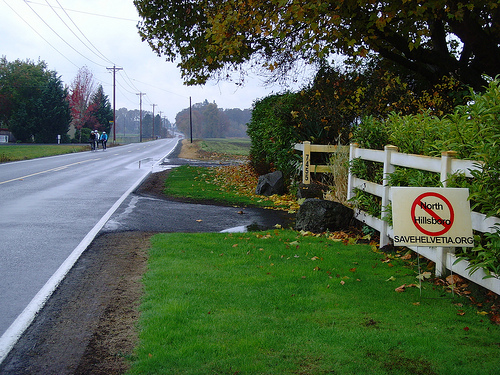<image>
Can you confirm if the plant is in front of the sign board? No. The plant is not in front of the sign board. The spatial positioning shows a different relationship between these objects. 